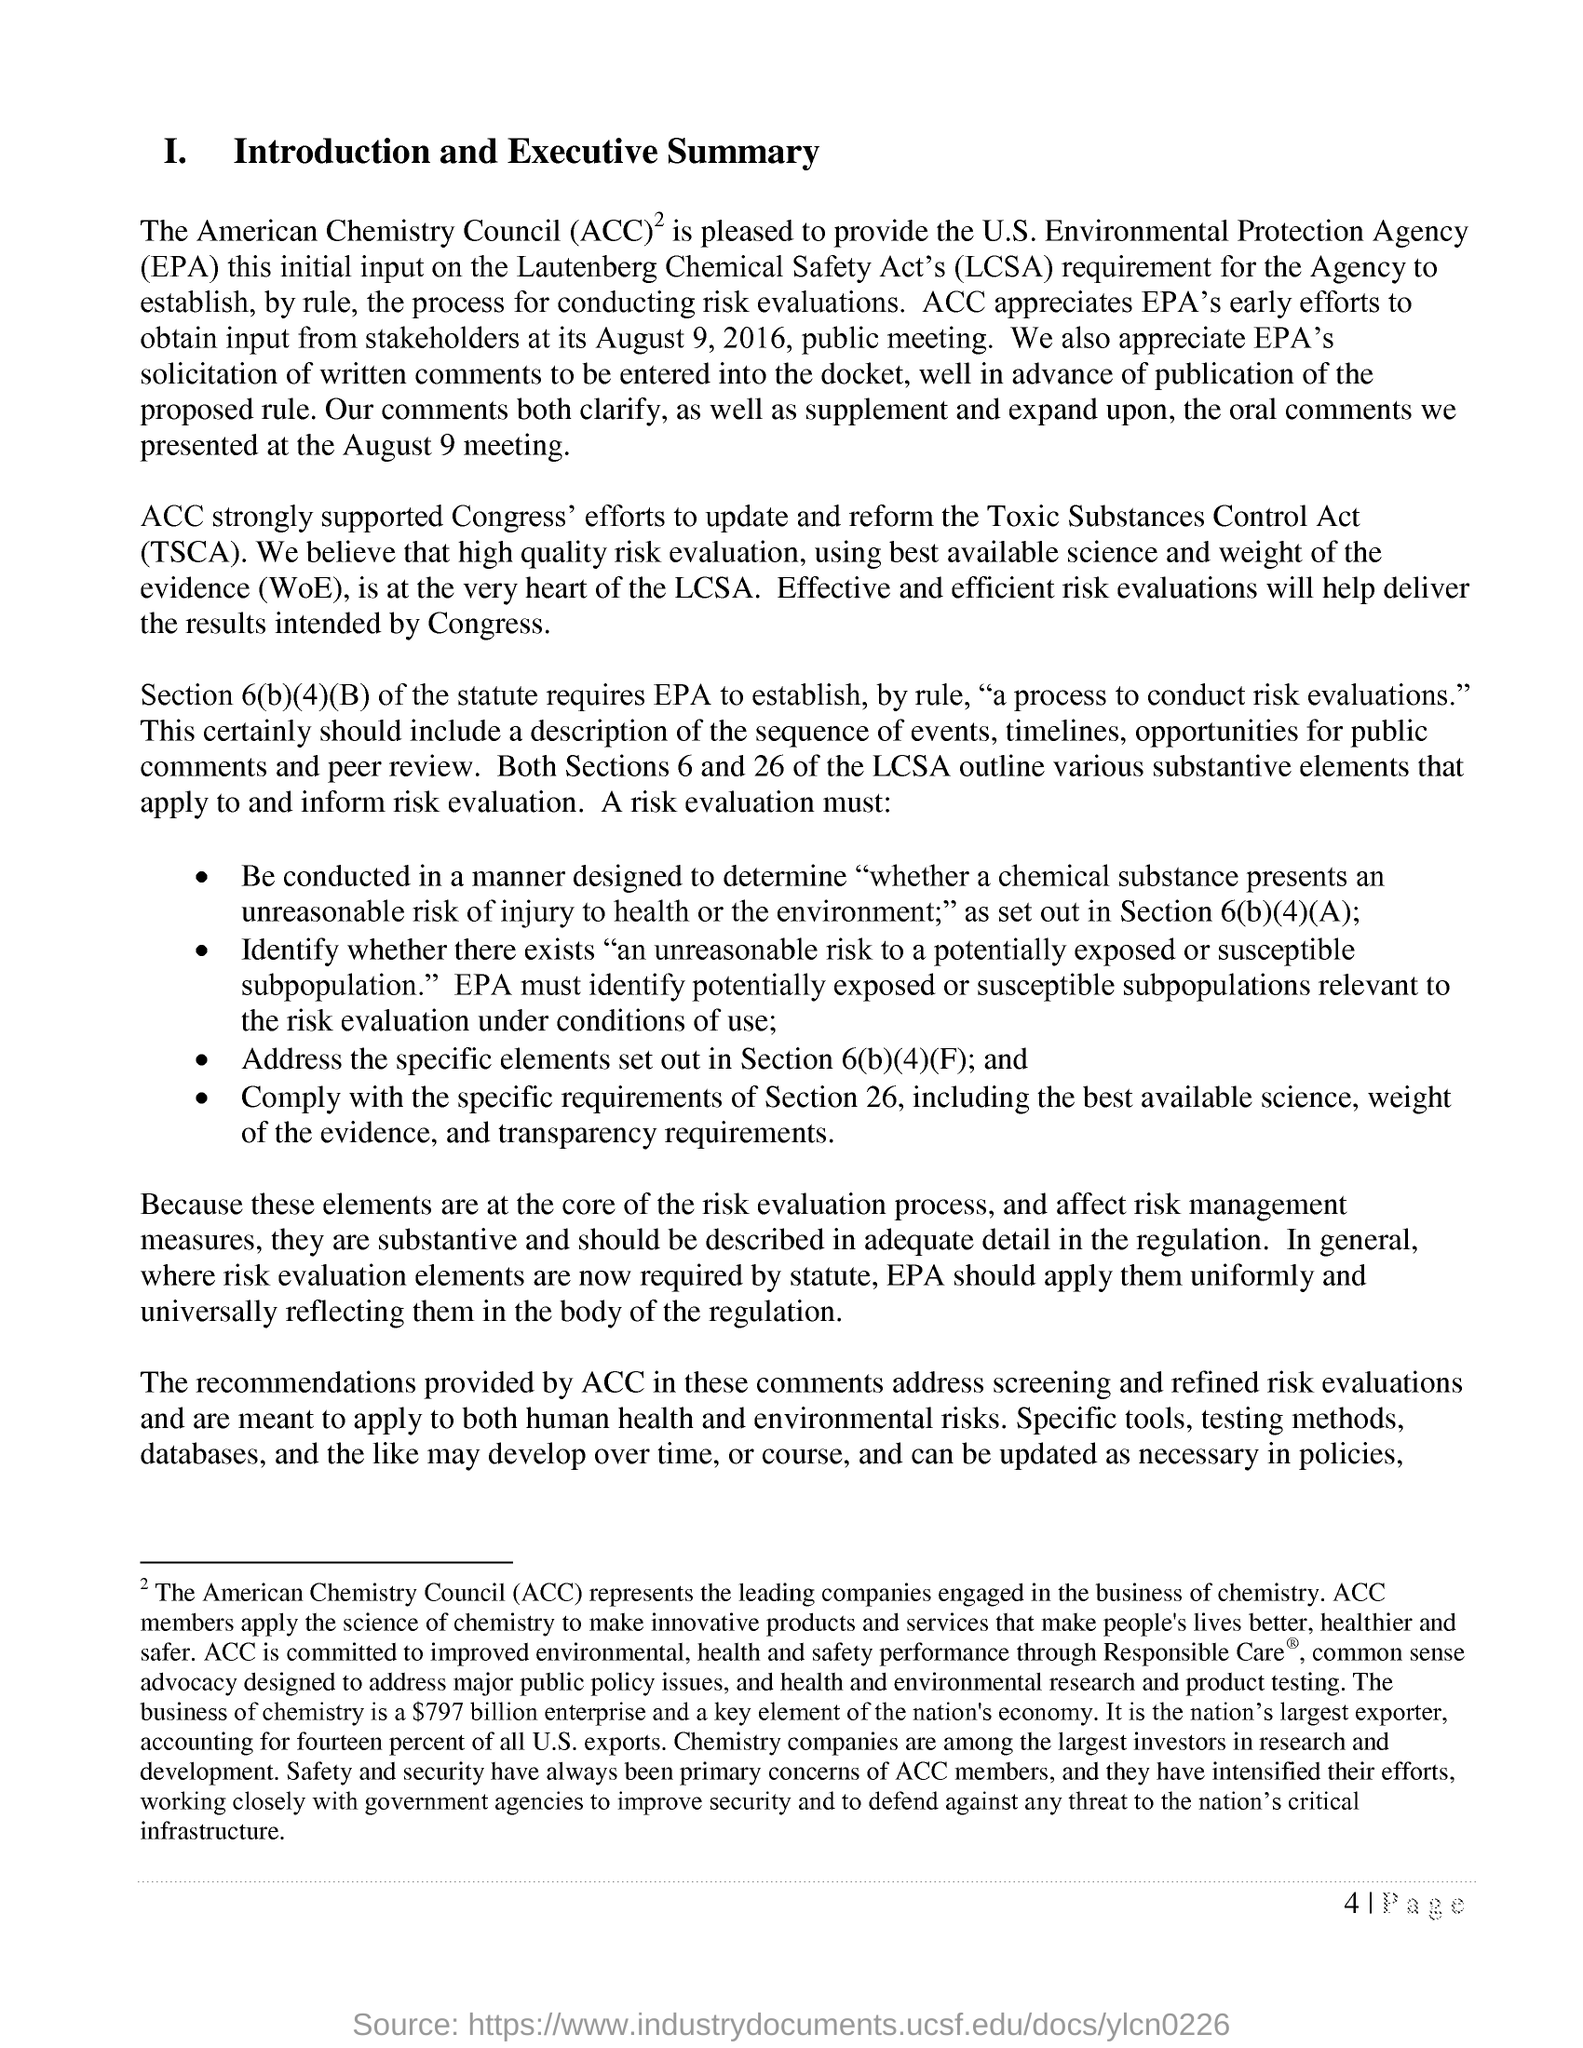Mention a couple of crucial points in this snapshot. The Toxic Substances Control Act, or TSCA, is a federal statute that regulates the production, use, and disposal of toxic chemicals in the United States. The American Chemistry Council, commonly abbreviated as ACC, is a trade association representing the business of chemistry in the United States. ACC strongly supports Congress' efforts to pass the Toxic Substances Control Act. It is my conviction that effective and efficient risk evaluations are essential in delivering the desired outcomes intended by Congress. 